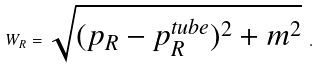Convert formula to latex. <formula><loc_0><loc_0><loc_500><loc_500>W _ { R } = \sqrt { ( p _ { R } - p _ { R } ^ { t u b e } ) ^ { 2 } + m ^ { 2 } } \ .</formula> 